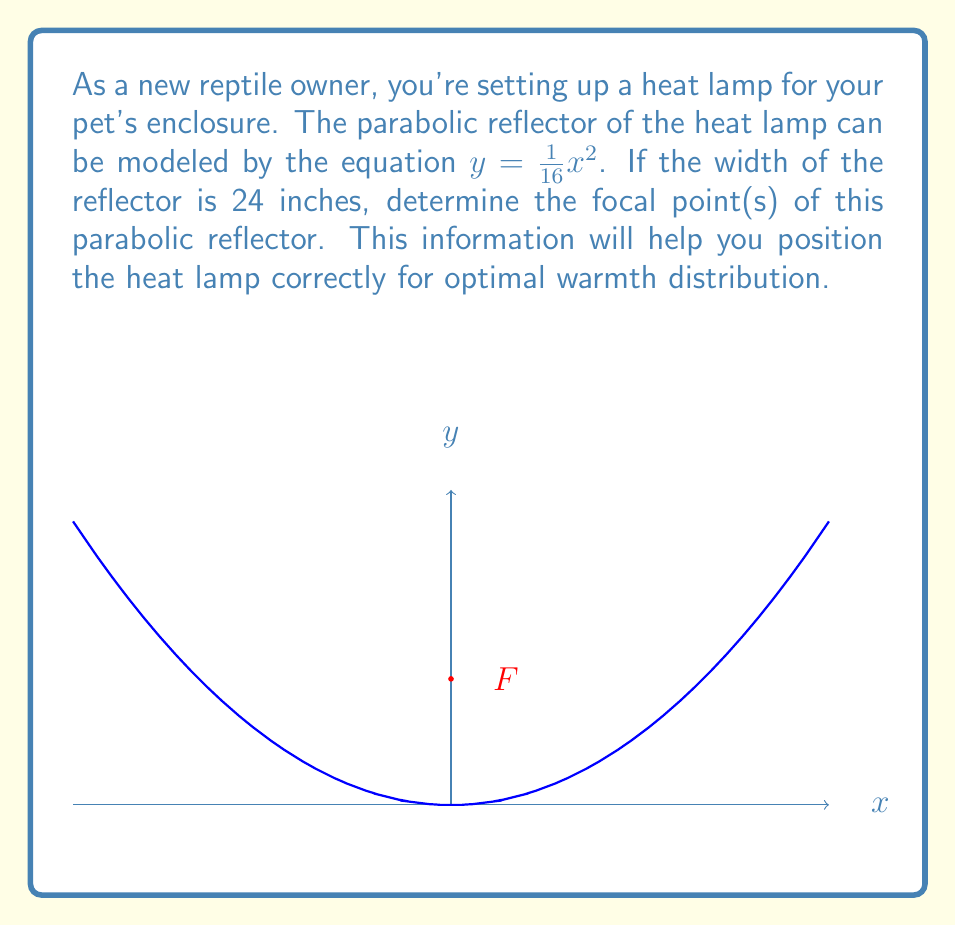What is the answer to this math problem? Let's approach this step-by-step:

1) The general equation of a parabola with vertex at the origin is:

   $y = \frac{1}{4p}x^2$

   where $p$ is the distance from the vertex to the focus.

2) In our case, $y = \frac{1}{16}x^2$, so $\frac{1}{4p} = \frac{1}{16}$

3) Solving for $p$:
   $p = \frac{1}{4} \cdot 16 = 4$

4) This means the focal point is 4 units above the vertex on the y-axis.

5) The parabola opens upward, so the focal point will be at $(0, 4)$.

6) To verify, we can use the width of the reflector:
   - Width is 24 inches, so it extends 12 inches on each side of the y-axis.
   - At $x = 12$, $y = \frac{1}{16}(12)^2 = 9$

7) The focal length can also be calculated as $\frac{a^2}{4c}$ where $a$ is half the width and $c$ is the depth:
   $4 = \frac{12^2}{4(9)} = \frac{144}{36} = 4$

This confirms our calculation.
Answer: $(0, 4)$ 